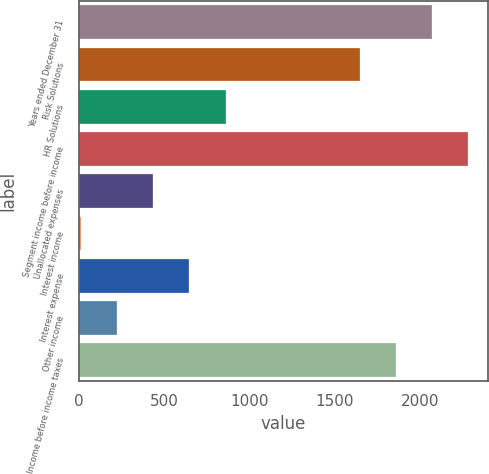Convert chart to OTSL. <chart><loc_0><loc_0><loc_500><loc_500><bar_chart><fcel>Years ended December 31<fcel>Risk Solutions<fcel>HR Solutions<fcel>Segment income before income<fcel>Unallocated expenses<fcel>Interest income<fcel>Interest expense<fcel>Other income<fcel>Income before income taxes<nl><fcel>2072.6<fcel>1648<fcel>859.2<fcel>2284.9<fcel>434.6<fcel>10<fcel>646.9<fcel>222.3<fcel>1860.3<nl></chart> 